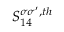Convert formula to latex. <formula><loc_0><loc_0><loc_500><loc_500>S _ { 1 4 } ^ { \sigma \sigma ^ { \prime } , t h }</formula> 